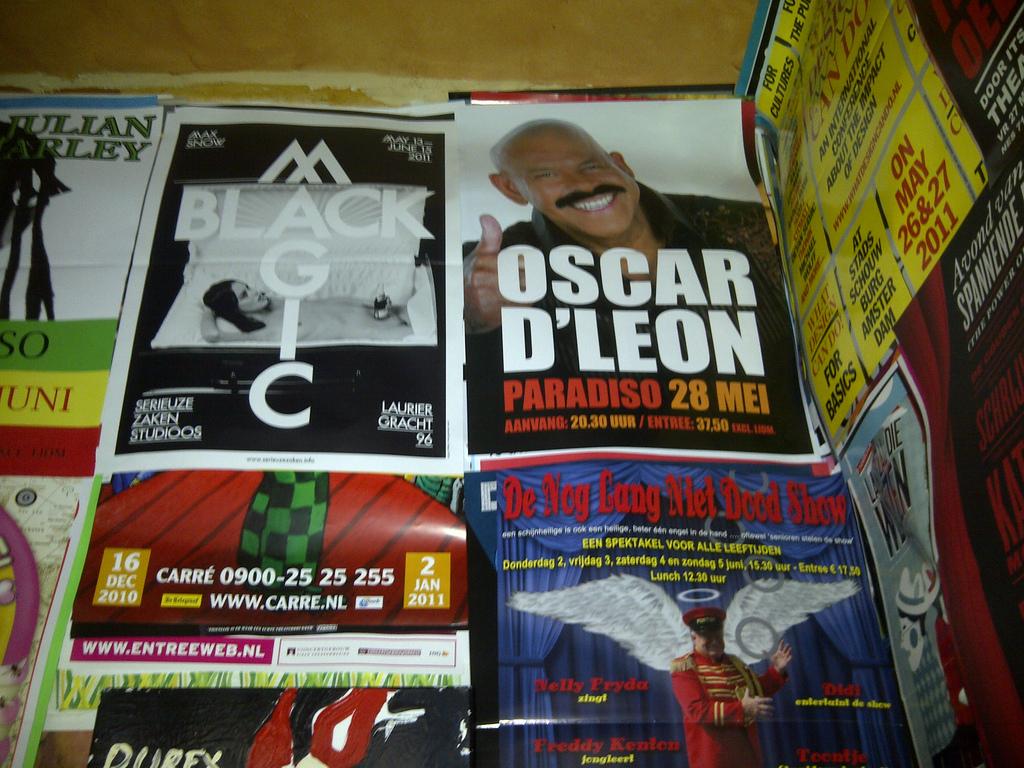What does it say under oscar d'leon?
Your response must be concise. Paradiso 28 mei. 